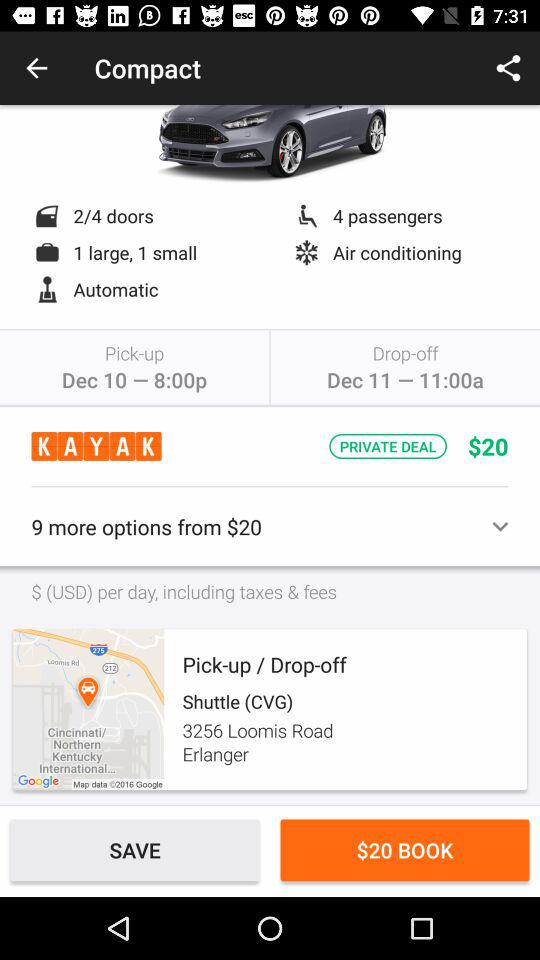How many doors are in the cab? There are 4 doors in the cab. 